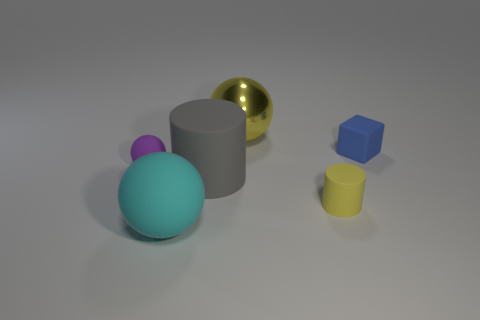Subtract all tiny rubber spheres. How many spheres are left? 2 Add 2 yellow metallic spheres. How many objects exist? 8 Subtract all purple balls. How many balls are left? 2 Subtract all cubes. How many objects are left? 5 Add 4 small blue metal objects. How many small blue metal objects exist? 4 Subtract 1 blue cubes. How many objects are left? 5 Subtract 1 cylinders. How many cylinders are left? 1 Subtract all green spheres. Subtract all brown cylinders. How many spheres are left? 3 Subtract all big blue cubes. Subtract all metallic balls. How many objects are left? 5 Add 6 big yellow things. How many big yellow things are left? 7 